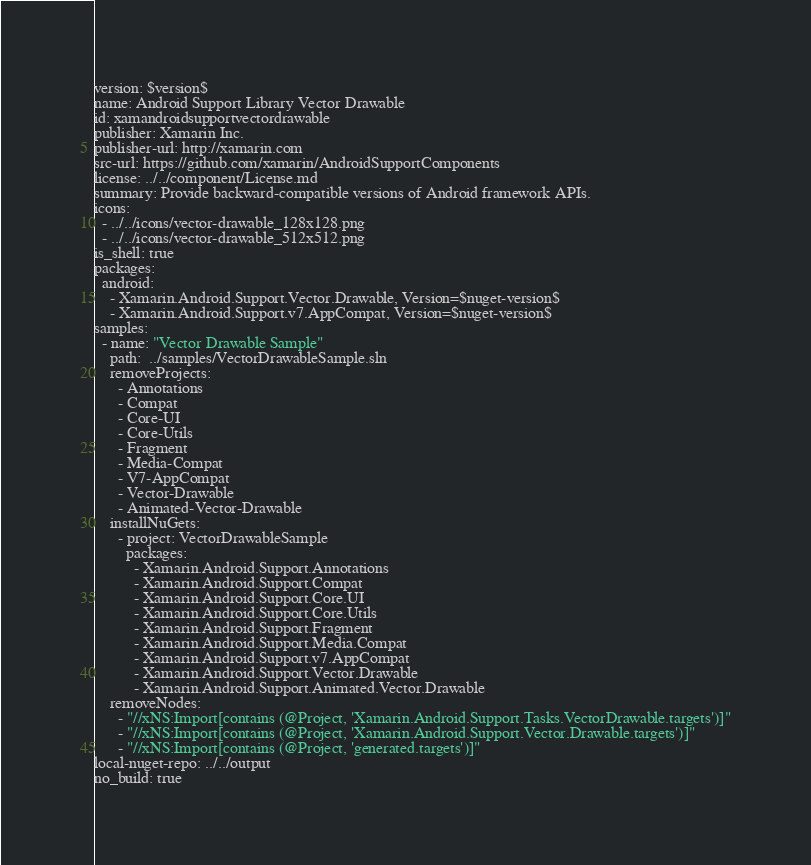<code> <loc_0><loc_0><loc_500><loc_500><_YAML_>version: $version$
name: Android Support Library Vector Drawable
id: xamandroidsupportvectordrawable
publisher: Xamarin Inc.
publisher-url: http://xamarin.com
src-url: https://github.com/xamarin/AndroidSupportComponents
license: ../../component/License.md
summary: Provide backward-compatible versions of Android framework APIs.
icons:
  - ../../icons/vector-drawable_128x128.png
  - ../../icons/vector-drawable_512x512.png
is_shell: true
packages:
  android:
    - Xamarin.Android.Support.Vector.Drawable, Version=$nuget-version$
    - Xamarin.Android.Support.v7.AppCompat, Version=$nuget-version$
samples:
  - name: "Vector Drawable Sample"
    path:  ../samples/VectorDrawableSample.sln
    removeProjects:
      - Annotations
      - Compat
      - Core-UI
      - Core-Utils
      - Fragment
      - Media-Compat
      - V7-AppCompat
      - Vector-Drawable
      - Animated-Vector-Drawable
    installNuGets:
      - project: VectorDrawableSample
        packages:
          - Xamarin.Android.Support.Annotations
          - Xamarin.Android.Support.Compat
          - Xamarin.Android.Support.Core.UI
          - Xamarin.Android.Support.Core.Utils
          - Xamarin.Android.Support.Fragment
          - Xamarin.Android.Support.Media.Compat
          - Xamarin.Android.Support.v7.AppCompat
          - Xamarin.Android.Support.Vector.Drawable
          - Xamarin.Android.Support.Animated.Vector.Drawable
    removeNodes:
      - "//xNS:Import[contains (@Project, 'Xamarin.Android.Support.Tasks.VectorDrawable.targets')]"
      - "//xNS:Import[contains (@Project, 'Xamarin.Android.Support.Vector.Drawable.targets')]"
      - "//xNS:Import[contains (@Project, 'generated.targets')]"
local-nuget-repo: ../../output
no_build: true
</code> 